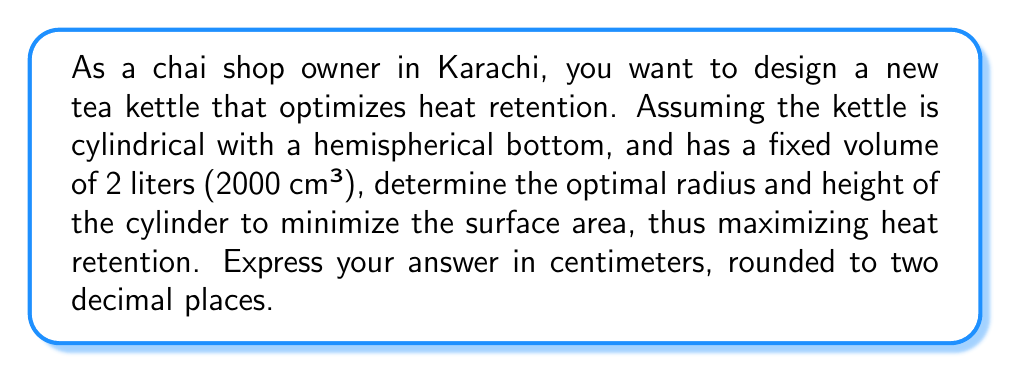Can you solve this math problem? Let's approach this step-by-step:

1) First, let's define our variables:
   $r$ = radius of the cylinder and hemisphere
   $h$ = height of the cylinder (not including the hemisphere)

2) The volume of the kettle is the sum of the cylinder volume and the hemisphere volume:
   $$V = \pi r^2 h + \frac{2}{3}\pi r^3 = 2000 \text{ cm}^3$$

3) The surface area of the kettle is the sum of the cylinder's lateral surface area and the hemisphere's surface area:
   $$A = 2\pi rh + 2\pi r^2$$

4) From the volume equation, we can express $h$ in terms of $r$:
   $$h = \frac{2000 - \frac{2}{3}\pi r^3}{\pi r^2}$$

5) Substituting this into the surface area equation:
   $$A = 2\pi r\left(\frac{2000 - \frac{2}{3}\pi r^3}{\pi r^2}\right) + 2\pi r^2$$
   $$A = \frac{4000}{r} - \frac{4}{3}\pi r + 2\pi r^2$$

6) To find the minimum surface area, we differentiate $A$ with respect to $r$ and set it to zero:
   $$\frac{dA}{dr} = -\frac{4000}{r^2} - \frac{4}{3}\pi + 4\pi r = 0$$

7) Multiplying through by $r^2$:
   $$-4000 - \frac{4}{3}\pi r^2 + 4\pi r^3 = 0$$

8) This is a cubic equation. Solving it numerically (using a computer algebra system or numerical methods) gives:
   $r \approx 7.63 \text{ cm}$

9) Substituting this back into the equation for $h$:
   $$h \approx \frac{2000 - \frac{2}{3}\pi (7.63)^3}{\pi (7.63)^2} \approx 7.63 \text{ cm}$$

Therefore, the optimal dimensions for the kettle are:
Radius ≈ 7.63 cm
Height (of cylinder part) ≈ 7.63 cm
Answer: The optimal radius and height of the cylinder are both approximately 7.63 cm. 